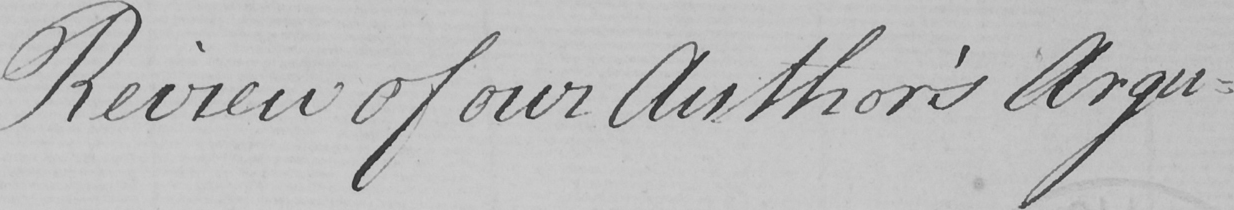Please transcribe the handwritten text in this image. Review for our Author ' s Argu= 